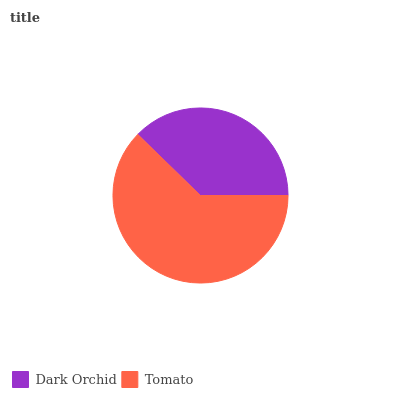Is Dark Orchid the minimum?
Answer yes or no. Yes. Is Tomato the maximum?
Answer yes or no. Yes. Is Tomato the minimum?
Answer yes or no. No. Is Tomato greater than Dark Orchid?
Answer yes or no. Yes. Is Dark Orchid less than Tomato?
Answer yes or no. Yes. Is Dark Orchid greater than Tomato?
Answer yes or no. No. Is Tomato less than Dark Orchid?
Answer yes or no. No. Is Tomato the high median?
Answer yes or no. Yes. Is Dark Orchid the low median?
Answer yes or no. Yes. Is Dark Orchid the high median?
Answer yes or no. No. Is Tomato the low median?
Answer yes or no. No. 